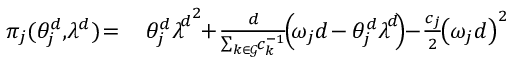Convert formula to latex. <formula><loc_0><loc_0><loc_500><loc_500>\begin{array} { r l } { \, \pi _ { j } ( \theta _ { j } ^ { d } , \, \lambda ^ { d } ) \, = } & { \ \, \theta _ { j } ^ { d } { { \lambda \, } ^ { d } } ^ { 2 } \, + \, \frac { d } { \sum _ { k \in \mathcal { G } } \, c _ { k } ^ { - 1 } } \, \left ( \, \omega _ { j } d \, - \theta _ { j } ^ { d } { { \lambda \, } ^ { d } } \, \right ) \, - \, \frac { c _ { j } } { 2 } \, { \left ( \omega _ { j } d \right ) } ^ { 2 } } \end{array}</formula> 